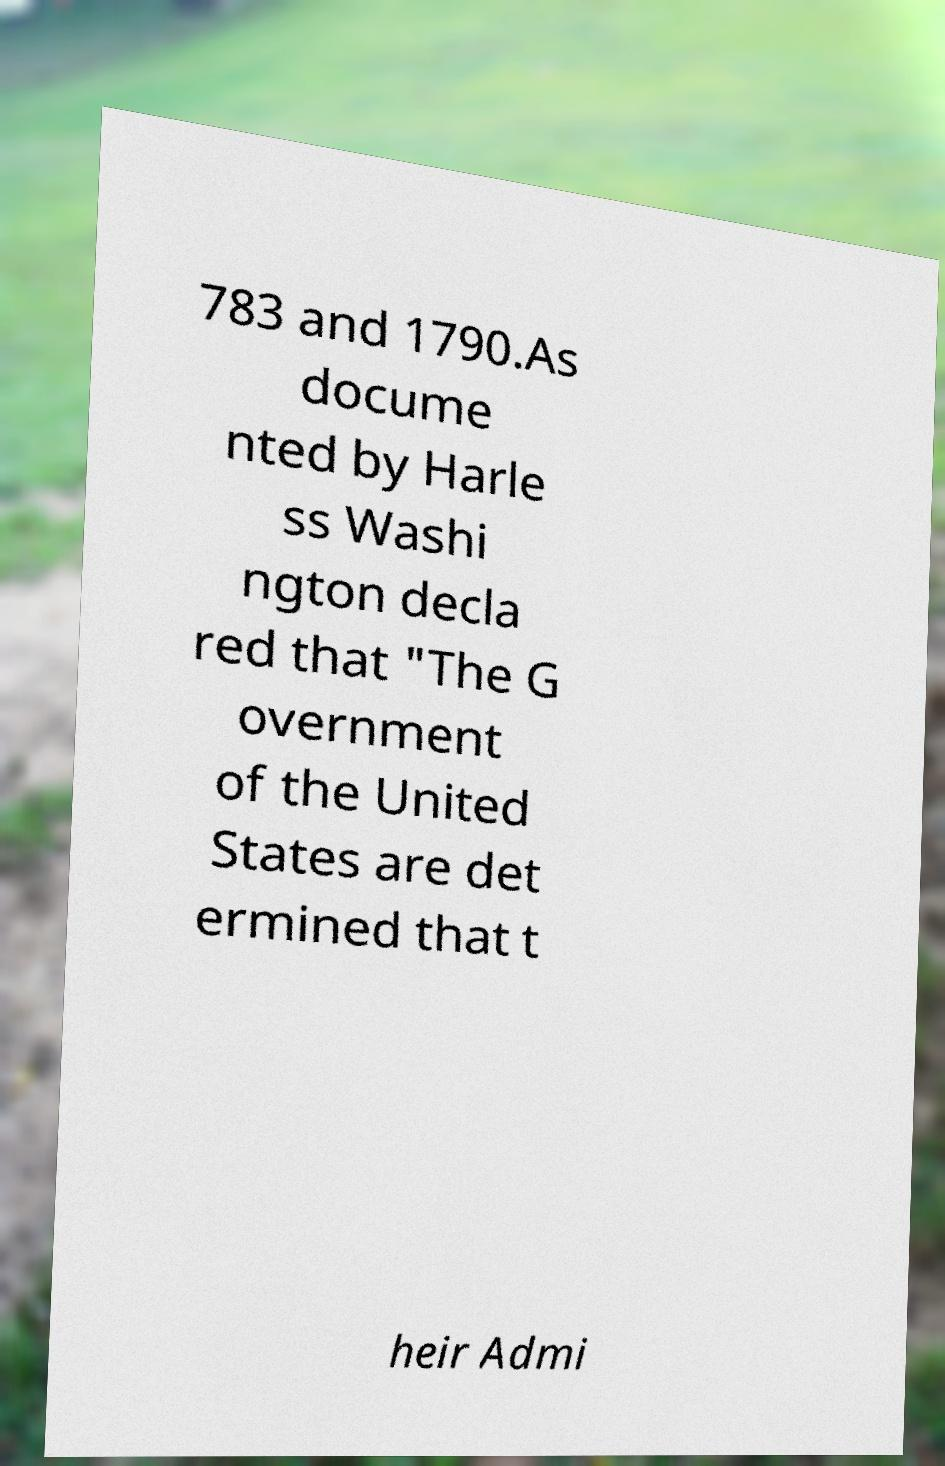Can you read and provide the text displayed in the image?This photo seems to have some interesting text. Can you extract and type it out for me? 783 and 1790.As docume nted by Harle ss Washi ngton decla red that "The G overnment of the United States are det ermined that t heir Admi 